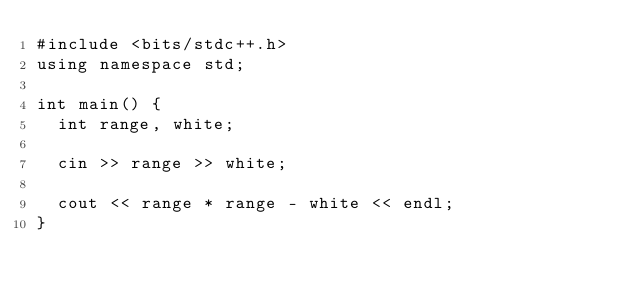Convert code to text. <code><loc_0><loc_0><loc_500><loc_500><_C++_>#include <bits/stdc++.h>
using namespace std;

int main() {
  int range, white;
  
  cin >> range >> white;
  
  cout << range * range - white << endl; 
}</code> 